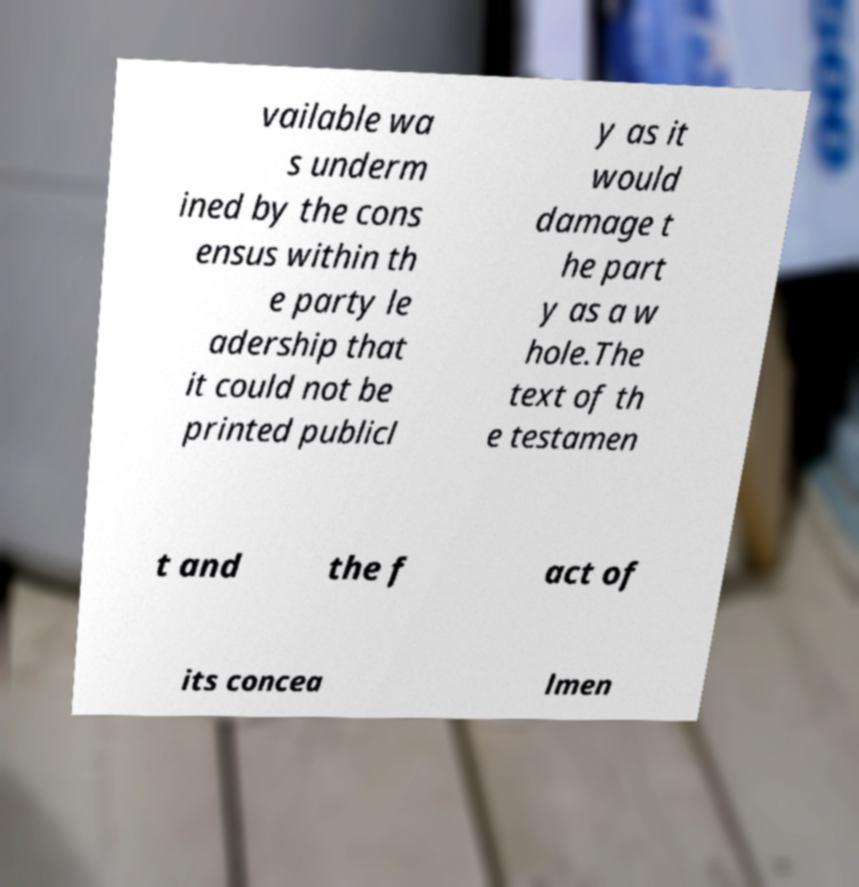There's text embedded in this image that I need extracted. Can you transcribe it verbatim? vailable wa s underm ined by the cons ensus within th e party le adership that it could not be printed publicl y as it would damage t he part y as a w hole.The text of th e testamen t and the f act of its concea lmen 